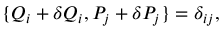<formula> <loc_0><loc_0><loc_500><loc_500>\{ Q _ { i } + \delta Q _ { i } , P _ { j } + \delta P _ { j } \} = \delta _ { i j } ,</formula> 